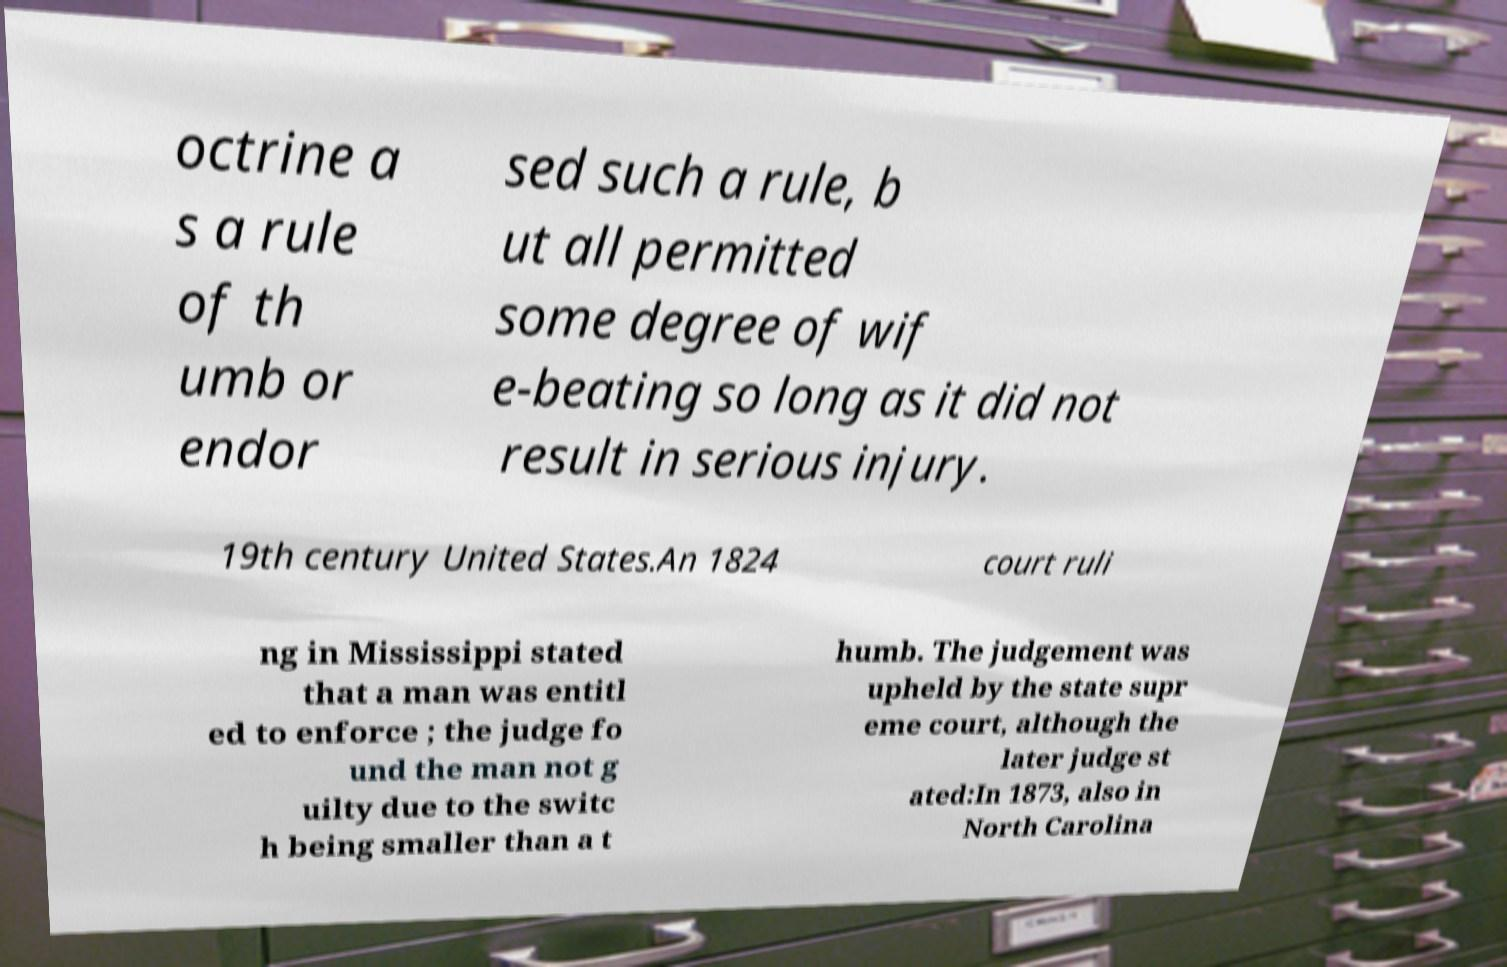Can you read and provide the text displayed in the image?This photo seems to have some interesting text. Can you extract and type it out for me? octrine a s a rule of th umb or endor sed such a rule, b ut all permitted some degree of wif e-beating so long as it did not result in serious injury. 19th century United States.An 1824 court ruli ng in Mississippi stated that a man was entitl ed to enforce ; the judge fo und the man not g uilty due to the switc h being smaller than a t humb. The judgement was upheld by the state supr eme court, although the later judge st ated:In 1873, also in North Carolina 